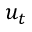Convert formula to latex. <formula><loc_0><loc_0><loc_500><loc_500>u _ { t }</formula> 